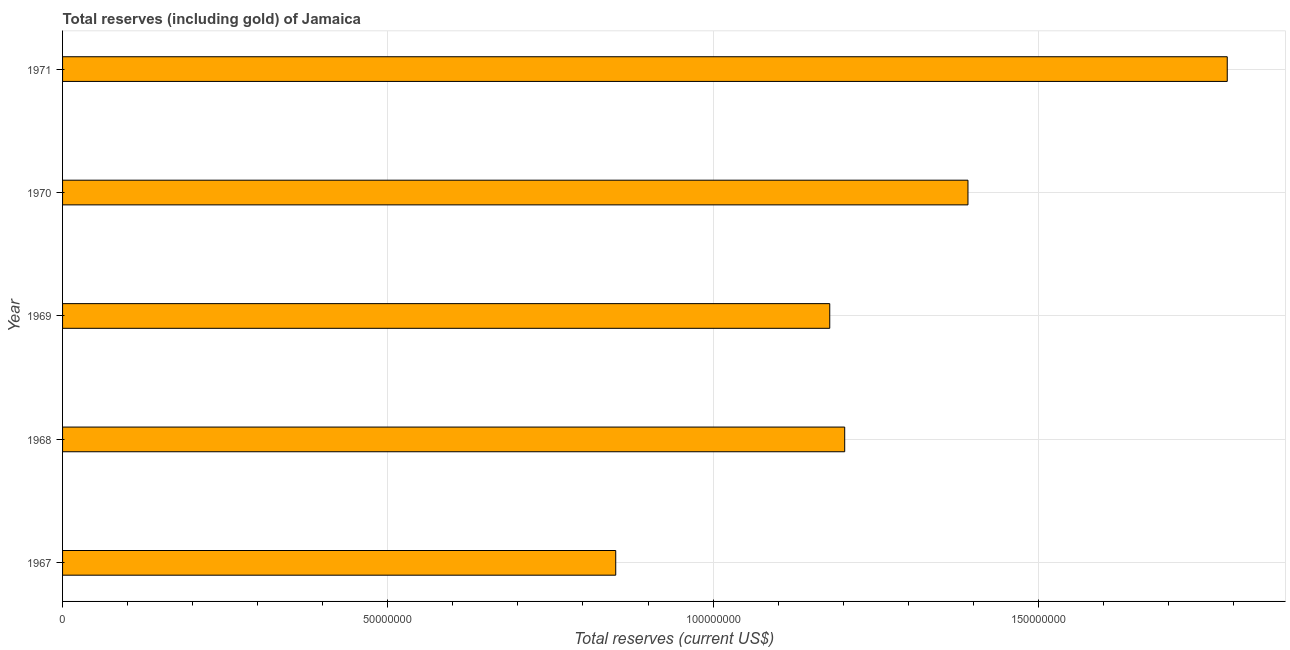Does the graph contain any zero values?
Keep it short and to the point. No. Does the graph contain grids?
Your response must be concise. Yes. What is the title of the graph?
Your response must be concise. Total reserves (including gold) of Jamaica. What is the label or title of the X-axis?
Offer a very short reply. Total reserves (current US$). What is the label or title of the Y-axis?
Ensure brevity in your answer.  Year. What is the total reserves (including gold) in 1969?
Make the answer very short. 1.18e+08. Across all years, what is the maximum total reserves (including gold)?
Your answer should be compact. 1.79e+08. Across all years, what is the minimum total reserves (including gold)?
Provide a succinct answer. 8.50e+07. In which year was the total reserves (including gold) maximum?
Your response must be concise. 1971. In which year was the total reserves (including gold) minimum?
Keep it short and to the point. 1967. What is the sum of the total reserves (including gold)?
Make the answer very short. 6.41e+08. What is the difference between the total reserves (including gold) in 1969 and 1971?
Keep it short and to the point. -6.11e+07. What is the average total reserves (including gold) per year?
Keep it short and to the point. 1.28e+08. What is the median total reserves (including gold)?
Offer a terse response. 1.20e+08. Do a majority of the years between 1969 and 1971 (inclusive) have total reserves (including gold) greater than 10000000 US$?
Offer a very short reply. Yes. What is the ratio of the total reserves (including gold) in 1967 to that in 1970?
Offer a very short reply. 0.61. Is the total reserves (including gold) in 1967 less than that in 1971?
Offer a very short reply. Yes. Is the difference between the total reserves (including gold) in 1970 and 1971 greater than the difference between any two years?
Ensure brevity in your answer.  No. What is the difference between the highest and the second highest total reserves (including gold)?
Offer a very short reply. 3.99e+07. What is the difference between the highest and the lowest total reserves (including gold)?
Your answer should be very brief. 9.40e+07. In how many years, is the total reserves (including gold) greater than the average total reserves (including gold) taken over all years?
Provide a short and direct response. 2. How many years are there in the graph?
Keep it short and to the point. 5. What is the difference between two consecutive major ticks on the X-axis?
Your response must be concise. 5.00e+07. What is the Total reserves (current US$) of 1967?
Your response must be concise. 8.50e+07. What is the Total reserves (current US$) of 1968?
Keep it short and to the point. 1.20e+08. What is the Total reserves (current US$) of 1969?
Your response must be concise. 1.18e+08. What is the Total reserves (current US$) in 1970?
Your answer should be compact. 1.39e+08. What is the Total reserves (current US$) of 1971?
Give a very brief answer. 1.79e+08. What is the difference between the Total reserves (current US$) in 1967 and 1968?
Keep it short and to the point. -3.52e+07. What is the difference between the Total reserves (current US$) in 1967 and 1969?
Ensure brevity in your answer.  -3.29e+07. What is the difference between the Total reserves (current US$) in 1967 and 1970?
Provide a short and direct response. -5.41e+07. What is the difference between the Total reserves (current US$) in 1967 and 1971?
Your answer should be compact. -9.40e+07. What is the difference between the Total reserves (current US$) in 1968 and 1969?
Provide a succinct answer. 2.30e+06. What is the difference between the Total reserves (current US$) in 1968 and 1970?
Offer a very short reply. -1.89e+07. What is the difference between the Total reserves (current US$) in 1968 and 1971?
Your answer should be compact. -5.88e+07. What is the difference between the Total reserves (current US$) in 1969 and 1970?
Provide a succinct answer. -2.12e+07. What is the difference between the Total reserves (current US$) in 1969 and 1971?
Ensure brevity in your answer.  -6.11e+07. What is the difference between the Total reserves (current US$) in 1970 and 1971?
Your answer should be compact. -3.99e+07. What is the ratio of the Total reserves (current US$) in 1967 to that in 1968?
Provide a succinct answer. 0.71. What is the ratio of the Total reserves (current US$) in 1967 to that in 1969?
Provide a succinct answer. 0.72. What is the ratio of the Total reserves (current US$) in 1967 to that in 1970?
Give a very brief answer. 0.61. What is the ratio of the Total reserves (current US$) in 1967 to that in 1971?
Make the answer very short. 0.47. What is the ratio of the Total reserves (current US$) in 1968 to that in 1969?
Offer a terse response. 1.02. What is the ratio of the Total reserves (current US$) in 1968 to that in 1970?
Keep it short and to the point. 0.86. What is the ratio of the Total reserves (current US$) in 1968 to that in 1971?
Your answer should be very brief. 0.67. What is the ratio of the Total reserves (current US$) in 1969 to that in 1970?
Your answer should be compact. 0.85. What is the ratio of the Total reserves (current US$) in 1969 to that in 1971?
Your response must be concise. 0.66. What is the ratio of the Total reserves (current US$) in 1970 to that in 1971?
Give a very brief answer. 0.78. 